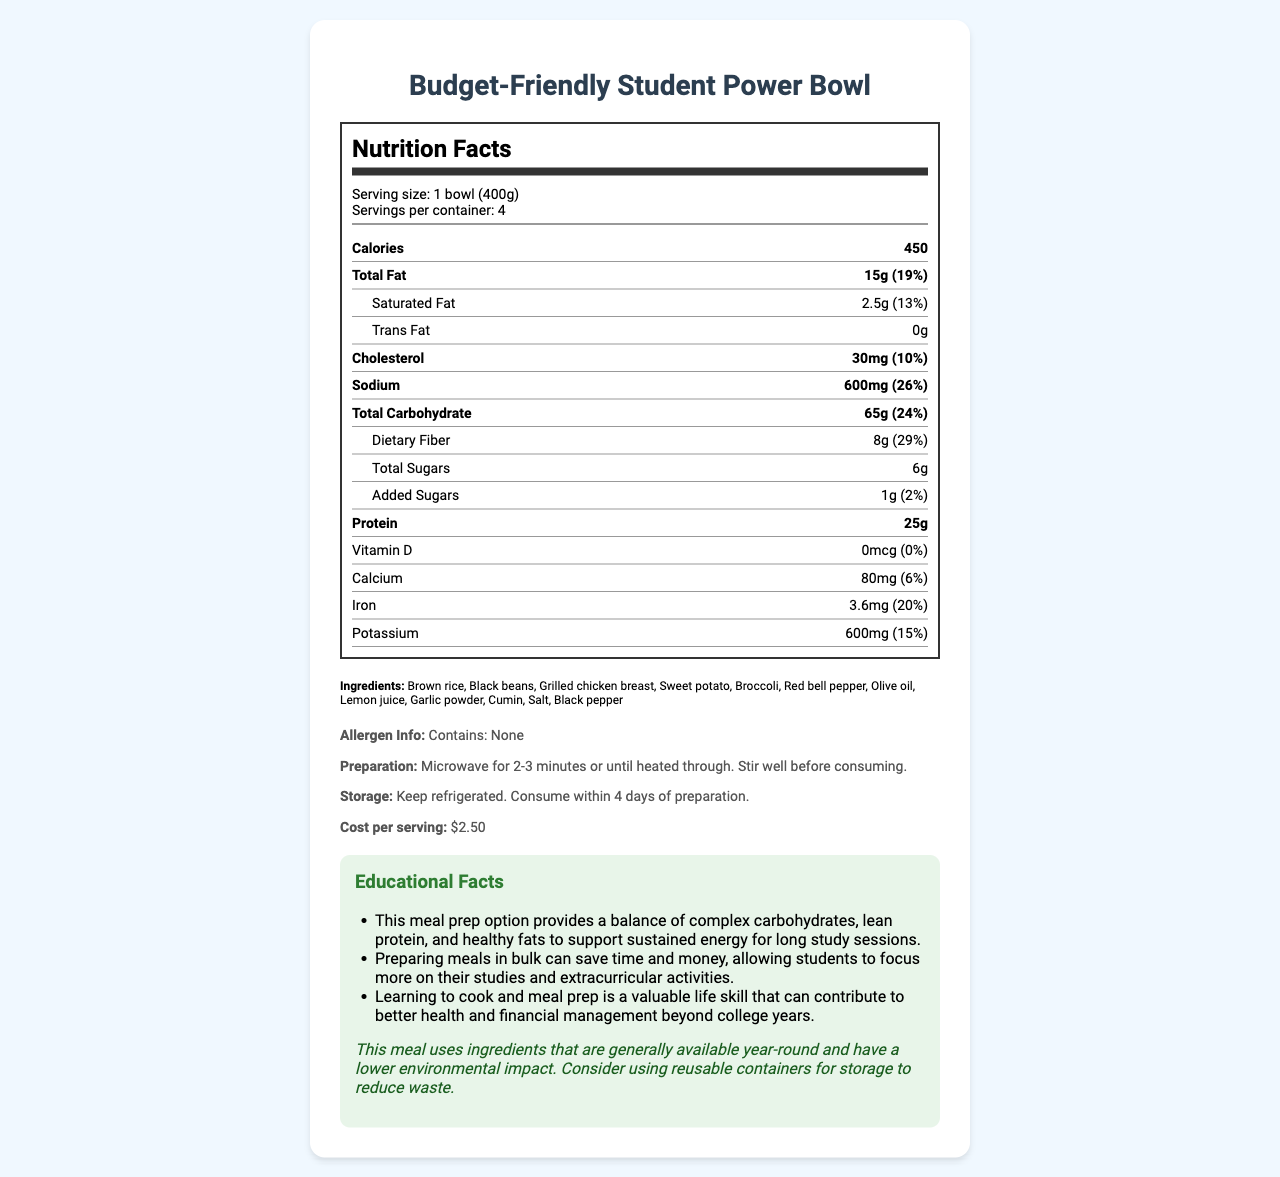what is the serving size of the Budget-Friendly Student Power Bowl? The serving size is clearly stated under "Serving size" in the document.
Answer: 1 bowl (400g) how many servings per container are there? The document lists "Servings per container" as 4.
Answer: 4 what is the total amount of calories per serving? The calories per serving are specified in the document.
Answer: 450 what is the percentage of daily value for sodium? The nutrition label in the document shows that sodium has a daily value percentage of 26%.
Answer: 26% what should you do before consuming this meal after microwaving? The instruction "Stir well before consuming" is part of the preparation instructions in the document.
Answer: Stir well before consuming how many grams of protein are in one serving? A. 15g B. 8g C. 25g D. 65g The document lists 25g of protein per serving.
Answer: C which ingredient is NOT listed in the Budget-Friendly Student Power Bowl? A. Broccoli B. Olive oil C. Cheese D. Sweet potato The document's ingredients list does not include cheese.
Answer: C does the nutrition facts label indicate any allergens? The document states "Contains: None" under allergen info, indicating no allergens.
Answer: No can the meal be stored at room temperature? The meal should be refrigerated as stated in the storage instructions.
Answer: No summarize the main idea of the document. The document presents a balanced and affordable meal option for college students with appropriate nutritional information and guidance on preparation, storage, and cost savings.
Answer: The document provides detailed nutrition facts, ingredients, preparation and storage instructions, cost per serving, and educational information about a budget-friendly meal prep option called the "Budget-Friendly Student Power Bowl." It highlights the meal's balance of nutrition and affordability specifically catered to college students. what is the source of vitamin D in this meal? The document does not specify any sources of vitamin D in the ingredients list or any other section.
Answer: Not enough information 